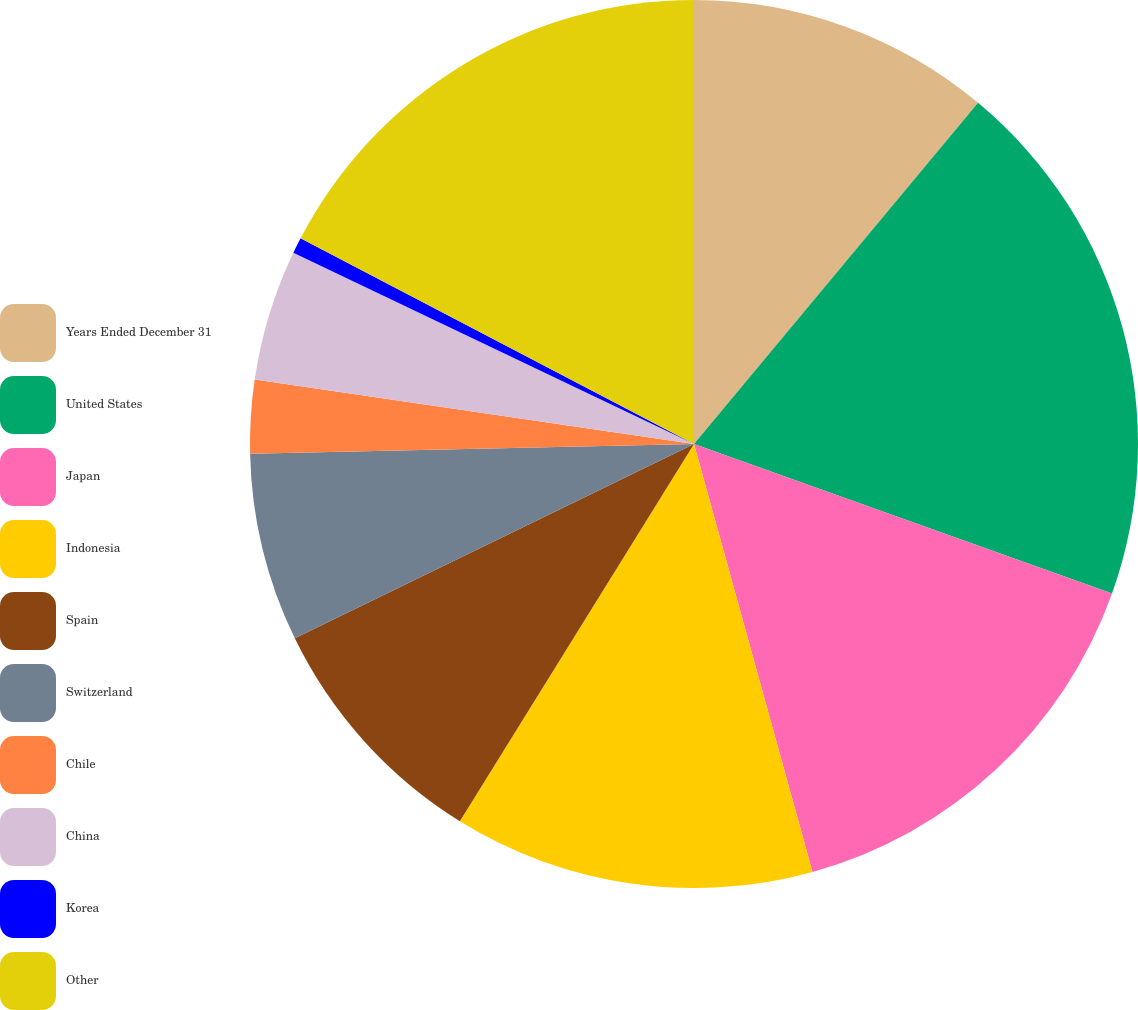Convert chart. <chart><loc_0><loc_0><loc_500><loc_500><pie_chart><fcel>Years Ended December 31<fcel>United States<fcel>Japan<fcel>Indonesia<fcel>Spain<fcel>Switzerland<fcel>Chile<fcel>China<fcel>Korea<fcel>Other<nl><fcel>11.05%<fcel>19.42%<fcel>15.23%<fcel>13.14%<fcel>8.95%<fcel>6.86%<fcel>2.67%<fcel>4.77%<fcel>0.58%<fcel>17.33%<nl></chart> 